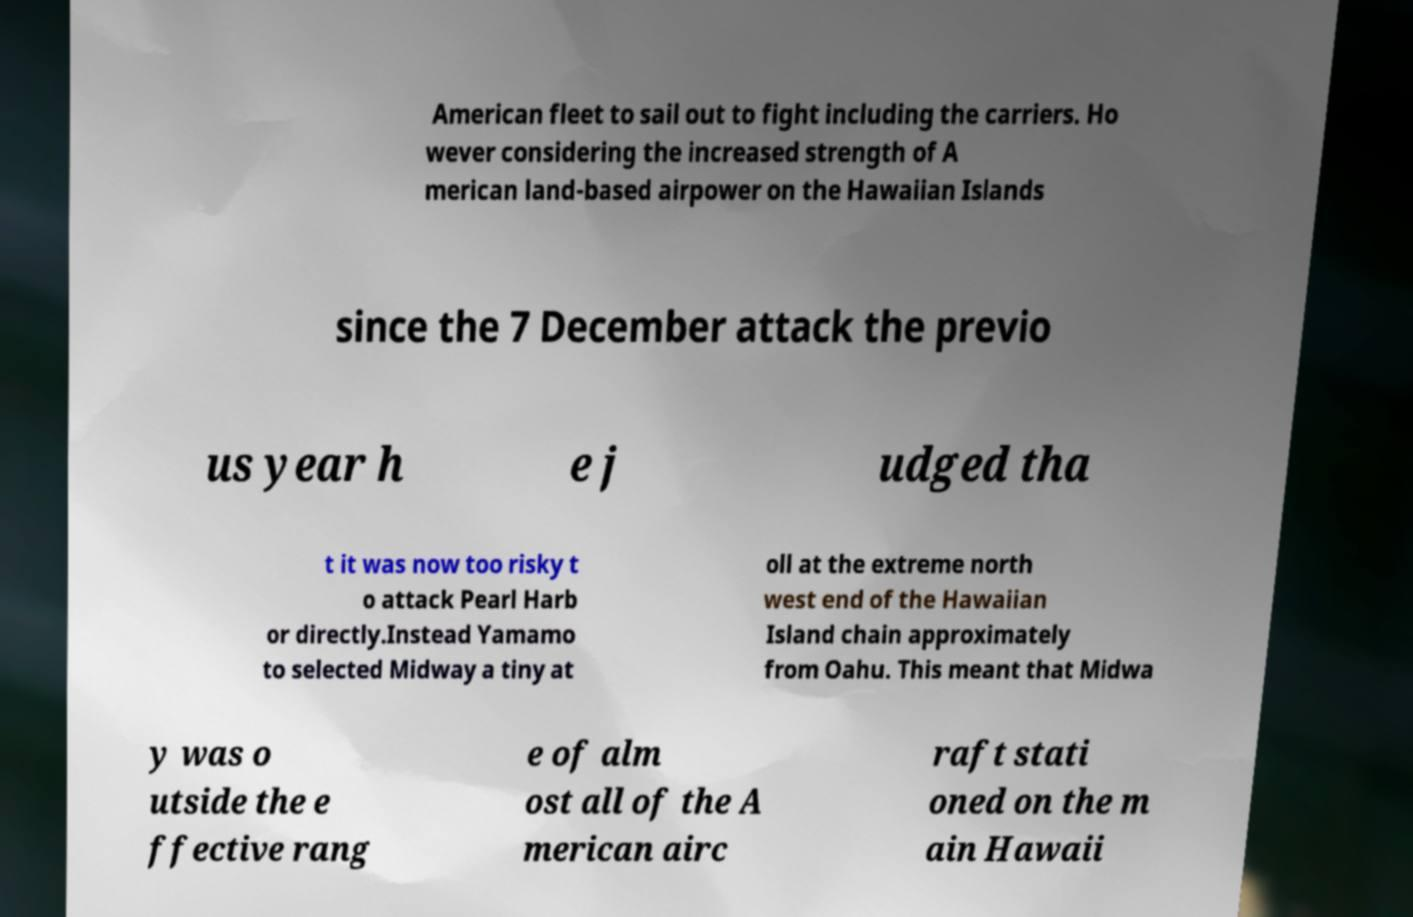I need the written content from this picture converted into text. Can you do that? American fleet to sail out to fight including the carriers. Ho wever considering the increased strength of A merican land-based airpower on the Hawaiian Islands since the 7 December attack the previo us year h e j udged tha t it was now too risky t o attack Pearl Harb or directly.Instead Yamamo to selected Midway a tiny at oll at the extreme north west end of the Hawaiian Island chain approximately from Oahu. This meant that Midwa y was o utside the e ffective rang e of alm ost all of the A merican airc raft stati oned on the m ain Hawaii 